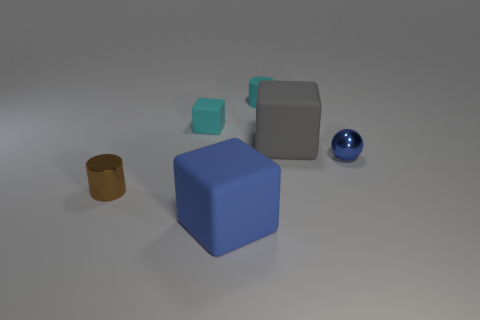The tiny cylinder behind the shiny thing that is right of the cyan cylinder is what color?
Your answer should be very brief. Cyan. Do the big thing that is left of the tiny cyan cylinder and the small shiny thing that is behind the brown cylinder have the same shape?
Ensure brevity in your answer.  No. What is the shape of the blue rubber thing that is the same size as the gray block?
Offer a very short reply. Cube. There is a tiny thing that is made of the same material as the small cyan cylinder; what is its color?
Keep it short and to the point. Cyan. Does the small blue metal object have the same shape as the big gray thing that is on the left side of the ball?
Provide a succinct answer. No. There is a big thing that is the same color as the shiny sphere; what is its material?
Give a very brief answer. Rubber. There is a object that is the same size as the blue matte block; what is it made of?
Your response must be concise. Rubber. Are there any other small matte cylinders that have the same color as the small rubber cylinder?
Give a very brief answer. No. The small thing that is right of the cyan cube and behind the gray rubber cube has what shape?
Offer a very short reply. Cylinder. What number of big blue things are the same material as the gray cube?
Keep it short and to the point. 1. 